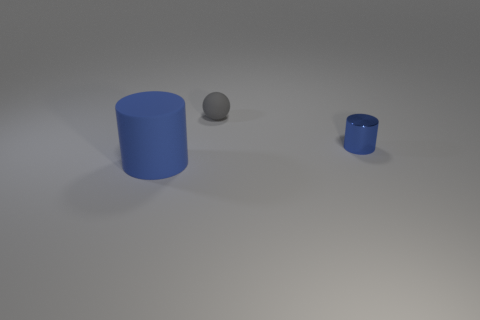There is a cylinder that is on the right side of the gray object; what is its size?
Your answer should be very brief. Small. Do the small sphere and the large rubber cylinder have the same color?
Provide a short and direct response. No. Are there any other things that are the same shape as the blue metallic object?
Your answer should be compact. Yes. What material is the other cylinder that is the same color as the metal cylinder?
Provide a short and direct response. Rubber. Are there the same number of matte cylinders in front of the large blue matte cylinder and tiny gray balls?
Offer a terse response. No. There is a tiny gray sphere; are there any things in front of it?
Your answer should be compact. Yes. There is a small blue metallic thing; is its shape the same as the thing that is in front of the metallic cylinder?
Offer a very short reply. Yes. The big cylinder that is the same material as the ball is what color?
Make the answer very short. Blue. The matte cylinder has what color?
Make the answer very short. Blue. Are the large cylinder and the blue thing behind the big matte cylinder made of the same material?
Your response must be concise. No. 